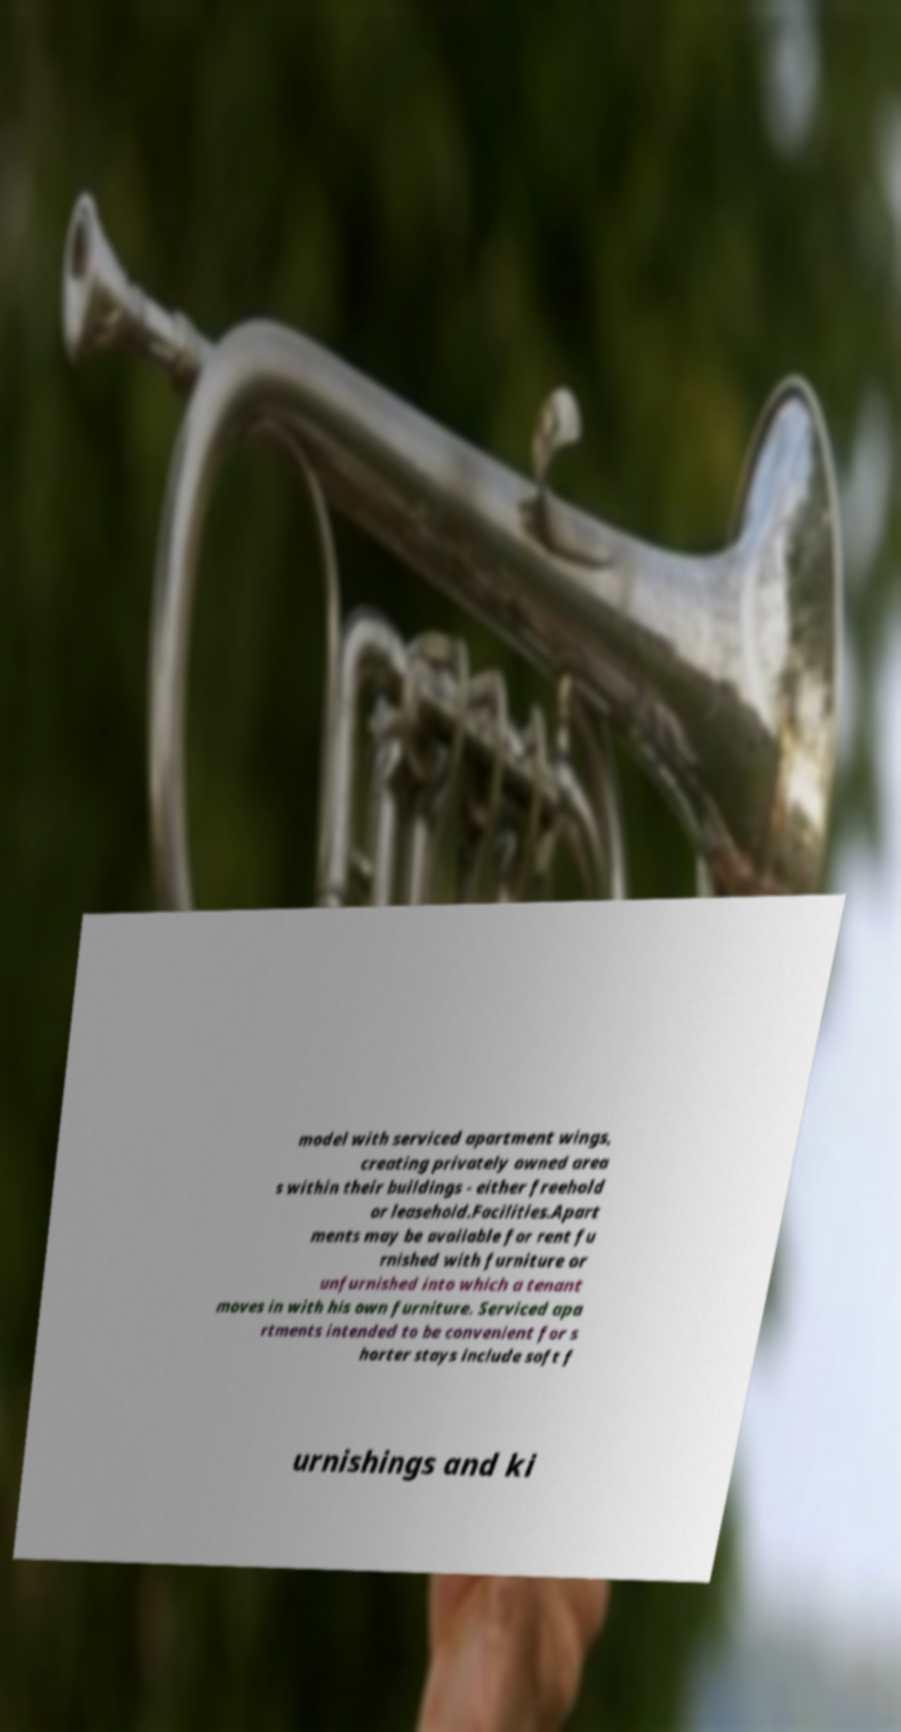There's text embedded in this image that I need extracted. Can you transcribe it verbatim? model with serviced apartment wings, creating privately owned area s within their buildings - either freehold or leasehold.Facilities.Apart ments may be available for rent fu rnished with furniture or unfurnished into which a tenant moves in with his own furniture. Serviced apa rtments intended to be convenient for s horter stays include soft f urnishings and ki 